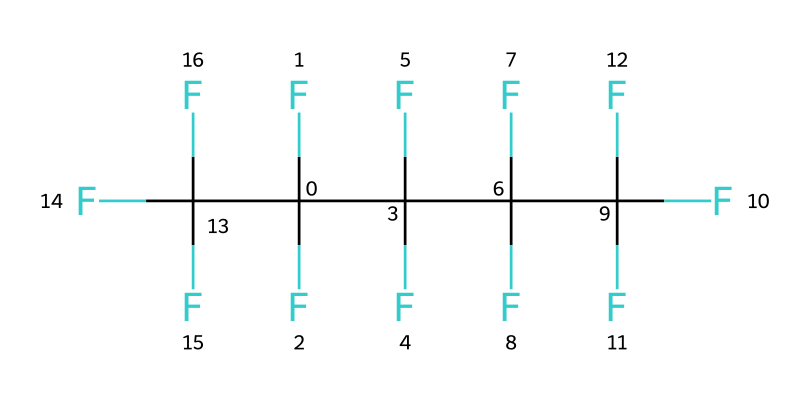How many carbon atoms are present in this fluoropolymer? By analyzing the SMILES representation, each "C" corresponds to a carbon atom. After counting all the carbon elements, there are a total of 8 "C" in the structure.
Answer: 8 What is the predominant type of atoms found in this fluoropolymer? The SMILES structure shows a significant number of "F" atoms compared to other types of atoms. Counting the fluorine atoms reveals that there are 20 "F" present in the chemical representation.
Answer: fluorine What type of bonding is likely present due to the high number of fluorine atoms? The presence of numerous fluorine atoms attached to carbon suggests a high level of covalent bonding, particularly considering the strength and stability associated with carbon-fluorine bonds.
Answer: covalent How could this fluoropolymer contribute to weather resistance in solar panels? Fluoropolymers are well-known for their chemical inertness and resistance to UV degradation, which enhances the durability of coatings used in various weather conditions on solar panels.
Answer: enhances durability What properties might be associated with this fluoropolymer structure? Given the structure's high fluorine content, the polymer is likely to exhibit low surface energy, chemical resistance, and thermal stability, making it suitable for outdoor applications.
Answer: low surface energy Is this polymer likely to be hydrophobic? The high fluorine content in the polymer typically acts to repel water due to the low surface energy, making this polymer hydrophobic in nature.
Answer: hydrophobic 